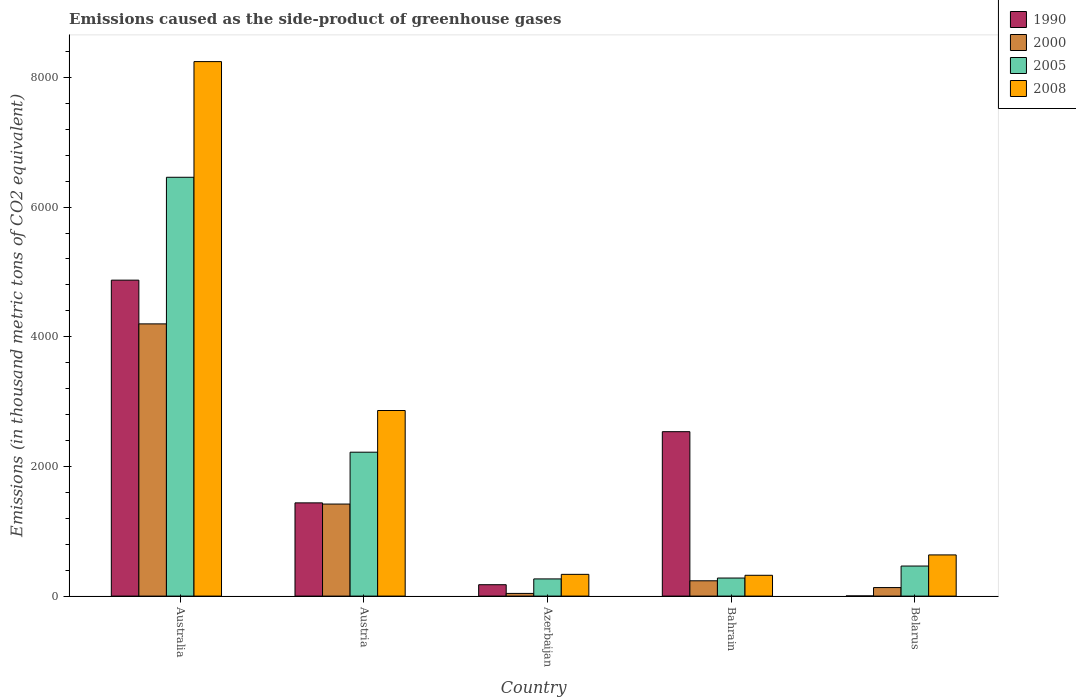Are the number of bars on each tick of the X-axis equal?
Your response must be concise. Yes. How many bars are there on the 1st tick from the left?
Your answer should be very brief. 4. What is the label of the 3rd group of bars from the left?
Give a very brief answer. Azerbaijan. What is the emissions caused as the side-product of greenhouse gases in 2008 in Australia?
Give a very brief answer. 8243.5. Across all countries, what is the maximum emissions caused as the side-product of greenhouse gases in 2000?
Your answer should be compact. 4198.3. Across all countries, what is the minimum emissions caused as the side-product of greenhouse gases in 2008?
Offer a very short reply. 320.9. In which country was the emissions caused as the side-product of greenhouse gases in 1990 minimum?
Give a very brief answer. Belarus. What is the total emissions caused as the side-product of greenhouse gases in 2005 in the graph?
Ensure brevity in your answer.  9686.4. What is the difference between the emissions caused as the side-product of greenhouse gases in 2000 in Bahrain and that in Belarus?
Your answer should be compact. 104.5. What is the difference between the emissions caused as the side-product of greenhouse gases in 2008 in Azerbaijan and the emissions caused as the side-product of greenhouse gases in 2000 in Australia?
Provide a succinct answer. -3863. What is the average emissions caused as the side-product of greenhouse gases in 2000 per country?
Offer a very short reply. 1205.36. What is the difference between the emissions caused as the side-product of greenhouse gases of/in 2000 and emissions caused as the side-product of greenhouse gases of/in 2005 in Australia?
Give a very brief answer. -2261.3. What is the ratio of the emissions caused as the side-product of greenhouse gases in 2005 in Australia to that in Austria?
Give a very brief answer. 2.91. What is the difference between the highest and the second highest emissions caused as the side-product of greenhouse gases in 2008?
Provide a short and direct response. -7608.3. What is the difference between the highest and the lowest emissions caused as the side-product of greenhouse gases in 2000?
Your answer should be very brief. 4157. What does the 3rd bar from the left in Bahrain represents?
Ensure brevity in your answer.  2005. What does the 3rd bar from the right in Bahrain represents?
Ensure brevity in your answer.  2000. Is it the case that in every country, the sum of the emissions caused as the side-product of greenhouse gases in 2008 and emissions caused as the side-product of greenhouse gases in 2000 is greater than the emissions caused as the side-product of greenhouse gases in 1990?
Provide a short and direct response. No. How many bars are there?
Your response must be concise. 20. Are all the bars in the graph horizontal?
Ensure brevity in your answer.  No. How many countries are there in the graph?
Offer a terse response. 5. What is the difference between two consecutive major ticks on the Y-axis?
Provide a short and direct response. 2000. Where does the legend appear in the graph?
Give a very brief answer. Top right. How many legend labels are there?
Make the answer very short. 4. What is the title of the graph?
Your answer should be very brief. Emissions caused as the side-product of greenhouse gases. Does "1972" appear as one of the legend labels in the graph?
Your answer should be compact. No. What is the label or title of the X-axis?
Provide a short and direct response. Country. What is the label or title of the Y-axis?
Provide a succinct answer. Emissions (in thousand metric tons of CO2 equivalent). What is the Emissions (in thousand metric tons of CO2 equivalent) in 1990 in Australia?
Provide a short and direct response. 4872.8. What is the Emissions (in thousand metric tons of CO2 equivalent) of 2000 in Australia?
Ensure brevity in your answer.  4198.3. What is the Emissions (in thousand metric tons of CO2 equivalent) of 2005 in Australia?
Provide a succinct answer. 6459.6. What is the Emissions (in thousand metric tons of CO2 equivalent) in 2008 in Australia?
Ensure brevity in your answer.  8243.5. What is the Emissions (in thousand metric tons of CO2 equivalent) of 1990 in Austria?
Ensure brevity in your answer.  1437.8. What is the Emissions (in thousand metric tons of CO2 equivalent) of 2000 in Austria?
Offer a very short reply. 1419.5. What is the Emissions (in thousand metric tons of CO2 equivalent) of 2005 in Austria?
Your answer should be very brief. 2219.5. What is the Emissions (in thousand metric tons of CO2 equivalent) of 2008 in Austria?
Make the answer very short. 2862.4. What is the Emissions (in thousand metric tons of CO2 equivalent) in 1990 in Azerbaijan?
Offer a terse response. 175.6. What is the Emissions (in thousand metric tons of CO2 equivalent) of 2000 in Azerbaijan?
Give a very brief answer. 41.3. What is the Emissions (in thousand metric tons of CO2 equivalent) of 2005 in Azerbaijan?
Your answer should be very brief. 265.1. What is the Emissions (in thousand metric tons of CO2 equivalent) in 2008 in Azerbaijan?
Offer a very short reply. 335.3. What is the Emissions (in thousand metric tons of CO2 equivalent) in 1990 in Bahrain?
Your answer should be compact. 2535.7. What is the Emissions (in thousand metric tons of CO2 equivalent) in 2000 in Bahrain?
Offer a very short reply. 236.1. What is the Emissions (in thousand metric tons of CO2 equivalent) in 2005 in Bahrain?
Provide a succinct answer. 278.6. What is the Emissions (in thousand metric tons of CO2 equivalent) of 2008 in Bahrain?
Ensure brevity in your answer.  320.9. What is the Emissions (in thousand metric tons of CO2 equivalent) in 1990 in Belarus?
Provide a succinct answer. 2.6. What is the Emissions (in thousand metric tons of CO2 equivalent) of 2000 in Belarus?
Offer a terse response. 131.6. What is the Emissions (in thousand metric tons of CO2 equivalent) of 2005 in Belarus?
Provide a short and direct response. 463.6. What is the Emissions (in thousand metric tons of CO2 equivalent) of 2008 in Belarus?
Offer a terse response. 635.2. Across all countries, what is the maximum Emissions (in thousand metric tons of CO2 equivalent) in 1990?
Keep it short and to the point. 4872.8. Across all countries, what is the maximum Emissions (in thousand metric tons of CO2 equivalent) of 2000?
Keep it short and to the point. 4198.3. Across all countries, what is the maximum Emissions (in thousand metric tons of CO2 equivalent) in 2005?
Offer a very short reply. 6459.6. Across all countries, what is the maximum Emissions (in thousand metric tons of CO2 equivalent) of 2008?
Your response must be concise. 8243.5. Across all countries, what is the minimum Emissions (in thousand metric tons of CO2 equivalent) in 1990?
Provide a succinct answer. 2.6. Across all countries, what is the minimum Emissions (in thousand metric tons of CO2 equivalent) in 2000?
Provide a succinct answer. 41.3. Across all countries, what is the minimum Emissions (in thousand metric tons of CO2 equivalent) in 2005?
Make the answer very short. 265.1. Across all countries, what is the minimum Emissions (in thousand metric tons of CO2 equivalent) in 2008?
Offer a very short reply. 320.9. What is the total Emissions (in thousand metric tons of CO2 equivalent) of 1990 in the graph?
Ensure brevity in your answer.  9024.5. What is the total Emissions (in thousand metric tons of CO2 equivalent) of 2000 in the graph?
Provide a short and direct response. 6026.8. What is the total Emissions (in thousand metric tons of CO2 equivalent) in 2005 in the graph?
Give a very brief answer. 9686.4. What is the total Emissions (in thousand metric tons of CO2 equivalent) in 2008 in the graph?
Give a very brief answer. 1.24e+04. What is the difference between the Emissions (in thousand metric tons of CO2 equivalent) in 1990 in Australia and that in Austria?
Your answer should be compact. 3435. What is the difference between the Emissions (in thousand metric tons of CO2 equivalent) of 2000 in Australia and that in Austria?
Your answer should be compact. 2778.8. What is the difference between the Emissions (in thousand metric tons of CO2 equivalent) of 2005 in Australia and that in Austria?
Keep it short and to the point. 4240.1. What is the difference between the Emissions (in thousand metric tons of CO2 equivalent) of 2008 in Australia and that in Austria?
Keep it short and to the point. 5381.1. What is the difference between the Emissions (in thousand metric tons of CO2 equivalent) in 1990 in Australia and that in Azerbaijan?
Your answer should be compact. 4697.2. What is the difference between the Emissions (in thousand metric tons of CO2 equivalent) in 2000 in Australia and that in Azerbaijan?
Provide a succinct answer. 4157. What is the difference between the Emissions (in thousand metric tons of CO2 equivalent) of 2005 in Australia and that in Azerbaijan?
Ensure brevity in your answer.  6194.5. What is the difference between the Emissions (in thousand metric tons of CO2 equivalent) of 2008 in Australia and that in Azerbaijan?
Offer a very short reply. 7908.2. What is the difference between the Emissions (in thousand metric tons of CO2 equivalent) in 1990 in Australia and that in Bahrain?
Your response must be concise. 2337.1. What is the difference between the Emissions (in thousand metric tons of CO2 equivalent) of 2000 in Australia and that in Bahrain?
Give a very brief answer. 3962.2. What is the difference between the Emissions (in thousand metric tons of CO2 equivalent) of 2005 in Australia and that in Bahrain?
Your answer should be very brief. 6181. What is the difference between the Emissions (in thousand metric tons of CO2 equivalent) in 2008 in Australia and that in Bahrain?
Offer a terse response. 7922.6. What is the difference between the Emissions (in thousand metric tons of CO2 equivalent) of 1990 in Australia and that in Belarus?
Your answer should be compact. 4870.2. What is the difference between the Emissions (in thousand metric tons of CO2 equivalent) in 2000 in Australia and that in Belarus?
Offer a terse response. 4066.7. What is the difference between the Emissions (in thousand metric tons of CO2 equivalent) of 2005 in Australia and that in Belarus?
Keep it short and to the point. 5996. What is the difference between the Emissions (in thousand metric tons of CO2 equivalent) in 2008 in Australia and that in Belarus?
Keep it short and to the point. 7608.3. What is the difference between the Emissions (in thousand metric tons of CO2 equivalent) in 1990 in Austria and that in Azerbaijan?
Offer a very short reply. 1262.2. What is the difference between the Emissions (in thousand metric tons of CO2 equivalent) in 2000 in Austria and that in Azerbaijan?
Offer a very short reply. 1378.2. What is the difference between the Emissions (in thousand metric tons of CO2 equivalent) of 2005 in Austria and that in Azerbaijan?
Provide a succinct answer. 1954.4. What is the difference between the Emissions (in thousand metric tons of CO2 equivalent) of 2008 in Austria and that in Azerbaijan?
Give a very brief answer. 2527.1. What is the difference between the Emissions (in thousand metric tons of CO2 equivalent) of 1990 in Austria and that in Bahrain?
Ensure brevity in your answer.  -1097.9. What is the difference between the Emissions (in thousand metric tons of CO2 equivalent) in 2000 in Austria and that in Bahrain?
Offer a terse response. 1183.4. What is the difference between the Emissions (in thousand metric tons of CO2 equivalent) in 2005 in Austria and that in Bahrain?
Give a very brief answer. 1940.9. What is the difference between the Emissions (in thousand metric tons of CO2 equivalent) of 2008 in Austria and that in Bahrain?
Offer a very short reply. 2541.5. What is the difference between the Emissions (in thousand metric tons of CO2 equivalent) of 1990 in Austria and that in Belarus?
Your answer should be compact. 1435.2. What is the difference between the Emissions (in thousand metric tons of CO2 equivalent) of 2000 in Austria and that in Belarus?
Provide a short and direct response. 1287.9. What is the difference between the Emissions (in thousand metric tons of CO2 equivalent) in 2005 in Austria and that in Belarus?
Give a very brief answer. 1755.9. What is the difference between the Emissions (in thousand metric tons of CO2 equivalent) of 2008 in Austria and that in Belarus?
Make the answer very short. 2227.2. What is the difference between the Emissions (in thousand metric tons of CO2 equivalent) of 1990 in Azerbaijan and that in Bahrain?
Offer a very short reply. -2360.1. What is the difference between the Emissions (in thousand metric tons of CO2 equivalent) of 2000 in Azerbaijan and that in Bahrain?
Your response must be concise. -194.8. What is the difference between the Emissions (in thousand metric tons of CO2 equivalent) of 2005 in Azerbaijan and that in Bahrain?
Offer a terse response. -13.5. What is the difference between the Emissions (in thousand metric tons of CO2 equivalent) in 2008 in Azerbaijan and that in Bahrain?
Your response must be concise. 14.4. What is the difference between the Emissions (in thousand metric tons of CO2 equivalent) of 1990 in Azerbaijan and that in Belarus?
Offer a very short reply. 173. What is the difference between the Emissions (in thousand metric tons of CO2 equivalent) in 2000 in Azerbaijan and that in Belarus?
Keep it short and to the point. -90.3. What is the difference between the Emissions (in thousand metric tons of CO2 equivalent) in 2005 in Azerbaijan and that in Belarus?
Your response must be concise. -198.5. What is the difference between the Emissions (in thousand metric tons of CO2 equivalent) of 2008 in Azerbaijan and that in Belarus?
Provide a succinct answer. -299.9. What is the difference between the Emissions (in thousand metric tons of CO2 equivalent) in 1990 in Bahrain and that in Belarus?
Offer a terse response. 2533.1. What is the difference between the Emissions (in thousand metric tons of CO2 equivalent) in 2000 in Bahrain and that in Belarus?
Give a very brief answer. 104.5. What is the difference between the Emissions (in thousand metric tons of CO2 equivalent) in 2005 in Bahrain and that in Belarus?
Offer a terse response. -185. What is the difference between the Emissions (in thousand metric tons of CO2 equivalent) of 2008 in Bahrain and that in Belarus?
Provide a short and direct response. -314.3. What is the difference between the Emissions (in thousand metric tons of CO2 equivalent) in 1990 in Australia and the Emissions (in thousand metric tons of CO2 equivalent) in 2000 in Austria?
Ensure brevity in your answer.  3453.3. What is the difference between the Emissions (in thousand metric tons of CO2 equivalent) of 1990 in Australia and the Emissions (in thousand metric tons of CO2 equivalent) of 2005 in Austria?
Keep it short and to the point. 2653.3. What is the difference between the Emissions (in thousand metric tons of CO2 equivalent) in 1990 in Australia and the Emissions (in thousand metric tons of CO2 equivalent) in 2008 in Austria?
Your answer should be compact. 2010.4. What is the difference between the Emissions (in thousand metric tons of CO2 equivalent) in 2000 in Australia and the Emissions (in thousand metric tons of CO2 equivalent) in 2005 in Austria?
Offer a terse response. 1978.8. What is the difference between the Emissions (in thousand metric tons of CO2 equivalent) in 2000 in Australia and the Emissions (in thousand metric tons of CO2 equivalent) in 2008 in Austria?
Offer a very short reply. 1335.9. What is the difference between the Emissions (in thousand metric tons of CO2 equivalent) in 2005 in Australia and the Emissions (in thousand metric tons of CO2 equivalent) in 2008 in Austria?
Offer a terse response. 3597.2. What is the difference between the Emissions (in thousand metric tons of CO2 equivalent) in 1990 in Australia and the Emissions (in thousand metric tons of CO2 equivalent) in 2000 in Azerbaijan?
Offer a terse response. 4831.5. What is the difference between the Emissions (in thousand metric tons of CO2 equivalent) in 1990 in Australia and the Emissions (in thousand metric tons of CO2 equivalent) in 2005 in Azerbaijan?
Offer a very short reply. 4607.7. What is the difference between the Emissions (in thousand metric tons of CO2 equivalent) in 1990 in Australia and the Emissions (in thousand metric tons of CO2 equivalent) in 2008 in Azerbaijan?
Offer a very short reply. 4537.5. What is the difference between the Emissions (in thousand metric tons of CO2 equivalent) in 2000 in Australia and the Emissions (in thousand metric tons of CO2 equivalent) in 2005 in Azerbaijan?
Provide a short and direct response. 3933.2. What is the difference between the Emissions (in thousand metric tons of CO2 equivalent) of 2000 in Australia and the Emissions (in thousand metric tons of CO2 equivalent) of 2008 in Azerbaijan?
Offer a terse response. 3863. What is the difference between the Emissions (in thousand metric tons of CO2 equivalent) in 2005 in Australia and the Emissions (in thousand metric tons of CO2 equivalent) in 2008 in Azerbaijan?
Your answer should be compact. 6124.3. What is the difference between the Emissions (in thousand metric tons of CO2 equivalent) of 1990 in Australia and the Emissions (in thousand metric tons of CO2 equivalent) of 2000 in Bahrain?
Keep it short and to the point. 4636.7. What is the difference between the Emissions (in thousand metric tons of CO2 equivalent) of 1990 in Australia and the Emissions (in thousand metric tons of CO2 equivalent) of 2005 in Bahrain?
Make the answer very short. 4594.2. What is the difference between the Emissions (in thousand metric tons of CO2 equivalent) in 1990 in Australia and the Emissions (in thousand metric tons of CO2 equivalent) in 2008 in Bahrain?
Your answer should be very brief. 4551.9. What is the difference between the Emissions (in thousand metric tons of CO2 equivalent) in 2000 in Australia and the Emissions (in thousand metric tons of CO2 equivalent) in 2005 in Bahrain?
Ensure brevity in your answer.  3919.7. What is the difference between the Emissions (in thousand metric tons of CO2 equivalent) in 2000 in Australia and the Emissions (in thousand metric tons of CO2 equivalent) in 2008 in Bahrain?
Make the answer very short. 3877.4. What is the difference between the Emissions (in thousand metric tons of CO2 equivalent) of 2005 in Australia and the Emissions (in thousand metric tons of CO2 equivalent) of 2008 in Bahrain?
Your answer should be very brief. 6138.7. What is the difference between the Emissions (in thousand metric tons of CO2 equivalent) in 1990 in Australia and the Emissions (in thousand metric tons of CO2 equivalent) in 2000 in Belarus?
Your answer should be compact. 4741.2. What is the difference between the Emissions (in thousand metric tons of CO2 equivalent) of 1990 in Australia and the Emissions (in thousand metric tons of CO2 equivalent) of 2005 in Belarus?
Your answer should be very brief. 4409.2. What is the difference between the Emissions (in thousand metric tons of CO2 equivalent) of 1990 in Australia and the Emissions (in thousand metric tons of CO2 equivalent) of 2008 in Belarus?
Offer a terse response. 4237.6. What is the difference between the Emissions (in thousand metric tons of CO2 equivalent) in 2000 in Australia and the Emissions (in thousand metric tons of CO2 equivalent) in 2005 in Belarus?
Ensure brevity in your answer.  3734.7. What is the difference between the Emissions (in thousand metric tons of CO2 equivalent) of 2000 in Australia and the Emissions (in thousand metric tons of CO2 equivalent) of 2008 in Belarus?
Ensure brevity in your answer.  3563.1. What is the difference between the Emissions (in thousand metric tons of CO2 equivalent) in 2005 in Australia and the Emissions (in thousand metric tons of CO2 equivalent) in 2008 in Belarus?
Your answer should be compact. 5824.4. What is the difference between the Emissions (in thousand metric tons of CO2 equivalent) in 1990 in Austria and the Emissions (in thousand metric tons of CO2 equivalent) in 2000 in Azerbaijan?
Give a very brief answer. 1396.5. What is the difference between the Emissions (in thousand metric tons of CO2 equivalent) of 1990 in Austria and the Emissions (in thousand metric tons of CO2 equivalent) of 2005 in Azerbaijan?
Ensure brevity in your answer.  1172.7. What is the difference between the Emissions (in thousand metric tons of CO2 equivalent) of 1990 in Austria and the Emissions (in thousand metric tons of CO2 equivalent) of 2008 in Azerbaijan?
Provide a succinct answer. 1102.5. What is the difference between the Emissions (in thousand metric tons of CO2 equivalent) of 2000 in Austria and the Emissions (in thousand metric tons of CO2 equivalent) of 2005 in Azerbaijan?
Keep it short and to the point. 1154.4. What is the difference between the Emissions (in thousand metric tons of CO2 equivalent) of 2000 in Austria and the Emissions (in thousand metric tons of CO2 equivalent) of 2008 in Azerbaijan?
Your answer should be very brief. 1084.2. What is the difference between the Emissions (in thousand metric tons of CO2 equivalent) of 2005 in Austria and the Emissions (in thousand metric tons of CO2 equivalent) of 2008 in Azerbaijan?
Keep it short and to the point. 1884.2. What is the difference between the Emissions (in thousand metric tons of CO2 equivalent) in 1990 in Austria and the Emissions (in thousand metric tons of CO2 equivalent) in 2000 in Bahrain?
Keep it short and to the point. 1201.7. What is the difference between the Emissions (in thousand metric tons of CO2 equivalent) of 1990 in Austria and the Emissions (in thousand metric tons of CO2 equivalent) of 2005 in Bahrain?
Keep it short and to the point. 1159.2. What is the difference between the Emissions (in thousand metric tons of CO2 equivalent) of 1990 in Austria and the Emissions (in thousand metric tons of CO2 equivalent) of 2008 in Bahrain?
Your answer should be very brief. 1116.9. What is the difference between the Emissions (in thousand metric tons of CO2 equivalent) in 2000 in Austria and the Emissions (in thousand metric tons of CO2 equivalent) in 2005 in Bahrain?
Your response must be concise. 1140.9. What is the difference between the Emissions (in thousand metric tons of CO2 equivalent) of 2000 in Austria and the Emissions (in thousand metric tons of CO2 equivalent) of 2008 in Bahrain?
Provide a short and direct response. 1098.6. What is the difference between the Emissions (in thousand metric tons of CO2 equivalent) in 2005 in Austria and the Emissions (in thousand metric tons of CO2 equivalent) in 2008 in Bahrain?
Make the answer very short. 1898.6. What is the difference between the Emissions (in thousand metric tons of CO2 equivalent) of 1990 in Austria and the Emissions (in thousand metric tons of CO2 equivalent) of 2000 in Belarus?
Provide a short and direct response. 1306.2. What is the difference between the Emissions (in thousand metric tons of CO2 equivalent) in 1990 in Austria and the Emissions (in thousand metric tons of CO2 equivalent) in 2005 in Belarus?
Offer a very short reply. 974.2. What is the difference between the Emissions (in thousand metric tons of CO2 equivalent) in 1990 in Austria and the Emissions (in thousand metric tons of CO2 equivalent) in 2008 in Belarus?
Your answer should be compact. 802.6. What is the difference between the Emissions (in thousand metric tons of CO2 equivalent) in 2000 in Austria and the Emissions (in thousand metric tons of CO2 equivalent) in 2005 in Belarus?
Give a very brief answer. 955.9. What is the difference between the Emissions (in thousand metric tons of CO2 equivalent) in 2000 in Austria and the Emissions (in thousand metric tons of CO2 equivalent) in 2008 in Belarus?
Ensure brevity in your answer.  784.3. What is the difference between the Emissions (in thousand metric tons of CO2 equivalent) of 2005 in Austria and the Emissions (in thousand metric tons of CO2 equivalent) of 2008 in Belarus?
Provide a short and direct response. 1584.3. What is the difference between the Emissions (in thousand metric tons of CO2 equivalent) of 1990 in Azerbaijan and the Emissions (in thousand metric tons of CO2 equivalent) of 2000 in Bahrain?
Keep it short and to the point. -60.5. What is the difference between the Emissions (in thousand metric tons of CO2 equivalent) in 1990 in Azerbaijan and the Emissions (in thousand metric tons of CO2 equivalent) in 2005 in Bahrain?
Provide a short and direct response. -103. What is the difference between the Emissions (in thousand metric tons of CO2 equivalent) of 1990 in Azerbaijan and the Emissions (in thousand metric tons of CO2 equivalent) of 2008 in Bahrain?
Offer a very short reply. -145.3. What is the difference between the Emissions (in thousand metric tons of CO2 equivalent) of 2000 in Azerbaijan and the Emissions (in thousand metric tons of CO2 equivalent) of 2005 in Bahrain?
Offer a very short reply. -237.3. What is the difference between the Emissions (in thousand metric tons of CO2 equivalent) of 2000 in Azerbaijan and the Emissions (in thousand metric tons of CO2 equivalent) of 2008 in Bahrain?
Make the answer very short. -279.6. What is the difference between the Emissions (in thousand metric tons of CO2 equivalent) of 2005 in Azerbaijan and the Emissions (in thousand metric tons of CO2 equivalent) of 2008 in Bahrain?
Give a very brief answer. -55.8. What is the difference between the Emissions (in thousand metric tons of CO2 equivalent) in 1990 in Azerbaijan and the Emissions (in thousand metric tons of CO2 equivalent) in 2000 in Belarus?
Your answer should be very brief. 44. What is the difference between the Emissions (in thousand metric tons of CO2 equivalent) in 1990 in Azerbaijan and the Emissions (in thousand metric tons of CO2 equivalent) in 2005 in Belarus?
Keep it short and to the point. -288. What is the difference between the Emissions (in thousand metric tons of CO2 equivalent) in 1990 in Azerbaijan and the Emissions (in thousand metric tons of CO2 equivalent) in 2008 in Belarus?
Your response must be concise. -459.6. What is the difference between the Emissions (in thousand metric tons of CO2 equivalent) of 2000 in Azerbaijan and the Emissions (in thousand metric tons of CO2 equivalent) of 2005 in Belarus?
Ensure brevity in your answer.  -422.3. What is the difference between the Emissions (in thousand metric tons of CO2 equivalent) in 2000 in Azerbaijan and the Emissions (in thousand metric tons of CO2 equivalent) in 2008 in Belarus?
Make the answer very short. -593.9. What is the difference between the Emissions (in thousand metric tons of CO2 equivalent) in 2005 in Azerbaijan and the Emissions (in thousand metric tons of CO2 equivalent) in 2008 in Belarus?
Provide a succinct answer. -370.1. What is the difference between the Emissions (in thousand metric tons of CO2 equivalent) of 1990 in Bahrain and the Emissions (in thousand metric tons of CO2 equivalent) of 2000 in Belarus?
Offer a terse response. 2404.1. What is the difference between the Emissions (in thousand metric tons of CO2 equivalent) of 1990 in Bahrain and the Emissions (in thousand metric tons of CO2 equivalent) of 2005 in Belarus?
Your answer should be compact. 2072.1. What is the difference between the Emissions (in thousand metric tons of CO2 equivalent) in 1990 in Bahrain and the Emissions (in thousand metric tons of CO2 equivalent) in 2008 in Belarus?
Your response must be concise. 1900.5. What is the difference between the Emissions (in thousand metric tons of CO2 equivalent) of 2000 in Bahrain and the Emissions (in thousand metric tons of CO2 equivalent) of 2005 in Belarus?
Provide a short and direct response. -227.5. What is the difference between the Emissions (in thousand metric tons of CO2 equivalent) of 2000 in Bahrain and the Emissions (in thousand metric tons of CO2 equivalent) of 2008 in Belarus?
Your answer should be compact. -399.1. What is the difference between the Emissions (in thousand metric tons of CO2 equivalent) of 2005 in Bahrain and the Emissions (in thousand metric tons of CO2 equivalent) of 2008 in Belarus?
Keep it short and to the point. -356.6. What is the average Emissions (in thousand metric tons of CO2 equivalent) in 1990 per country?
Make the answer very short. 1804.9. What is the average Emissions (in thousand metric tons of CO2 equivalent) in 2000 per country?
Your answer should be very brief. 1205.36. What is the average Emissions (in thousand metric tons of CO2 equivalent) in 2005 per country?
Offer a terse response. 1937.28. What is the average Emissions (in thousand metric tons of CO2 equivalent) in 2008 per country?
Keep it short and to the point. 2479.46. What is the difference between the Emissions (in thousand metric tons of CO2 equivalent) in 1990 and Emissions (in thousand metric tons of CO2 equivalent) in 2000 in Australia?
Offer a very short reply. 674.5. What is the difference between the Emissions (in thousand metric tons of CO2 equivalent) in 1990 and Emissions (in thousand metric tons of CO2 equivalent) in 2005 in Australia?
Your response must be concise. -1586.8. What is the difference between the Emissions (in thousand metric tons of CO2 equivalent) of 1990 and Emissions (in thousand metric tons of CO2 equivalent) of 2008 in Australia?
Your answer should be very brief. -3370.7. What is the difference between the Emissions (in thousand metric tons of CO2 equivalent) in 2000 and Emissions (in thousand metric tons of CO2 equivalent) in 2005 in Australia?
Ensure brevity in your answer.  -2261.3. What is the difference between the Emissions (in thousand metric tons of CO2 equivalent) in 2000 and Emissions (in thousand metric tons of CO2 equivalent) in 2008 in Australia?
Ensure brevity in your answer.  -4045.2. What is the difference between the Emissions (in thousand metric tons of CO2 equivalent) of 2005 and Emissions (in thousand metric tons of CO2 equivalent) of 2008 in Australia?
Keep it short and to the point. -1783.9. What is the difference between the Emissions (in thousand metric tons of CO2 equivalent) in 1990 and Emissions (in thousand metric tons of CO2 equivalent) in 2000 in Austria?
Offer a terse response. 18.3. What is the difference between the Emissions (in thousand metric tons of CO2 equivalent) of 1990 and Emissions (in thousand metric tons of CO2 equivalent) of 2005 in Austria?
Provide a short and direct response. -781.7. What is the difference between the Emissions (in thousand metric tons of CO2 equivalent) in 1990 and Emissions (in thousand metric tons of CO2 equivalent) in 2008 in Austria?
Provide a succinct answer. -1424.6. What is the difference between the Emissions (in thousand metric tons of CO2 equivalent) in 2000 and Emissions (in thousand metric tons of CO2 equivalent) in 2005 in Austria?
Offer a terse response. -800. What is the difference between the Emissions (in thousand metric tons of CO2 equivalent) of 2000 and Emissions (in thousand metric tons of CO2 equivalent) of 2008 in Austria?
Keep it short and to the point. -1442.9. What is the difference between the Emissions (in thousand metric tons of CO2 equivalent) of 2005 and Emissions (in thousand metric tons of CO2 equivalent) of 2008 in Austria?
Your answer should be compact. -642.9. What is the difference between the Emissions (in thousand metric tons of CO2 equivalent) in 1990 and Emissions (in thousand metric tons of CO2 equivalent) in 2000 in Azerbaijan?
Your answer should be very brief. 134.3. What is the difference between the Emissions (in thousand metric tons of CO2 equivalent) of 1990 and Emissions (in thousand metric tons of CO2 equivalent) of 2005 in Azerbaijan?
Give a very brief answer. -89.5. What is the difference between the Emissions (in thousand metric tons of CO2 equivalent) of 1990 and Emissions (in thousand metric tons of CO2 equivalent) of 2008 in Azerbaijan?
Keep it short and to the point. -159.7. What is the difference between the Emissions (in thousand metric tons of CO2 equivalent) of 2000 and Emissions (in thousand metric tons of CO2 equivalent) of 2005 in Azerbaijan?
Your response must be concise. -223.8. What is the difference between the Emissions (in thousand metric tons of CO2 equivalent) in 2000 and Emissions (in thousand metric tons of CO2 equivalent) in 2008 in Azerbaijan?
Offer a terse response. -294. What is the difference between the Emissions (in thousand metric tons of CO2 equivalent) of 2005 and Emissions (in thousand metric tons of CO2 equivalent) of 2008 in Azerbaijan?
Provide a succinct answer. -70.2. What is the difference between the Emissions (in thousand metric tons of CO2 equivalent) in 1990 and Emissions (in thousand metric tons of CO2 equivalent) in 2000 in Bahrain?
Provide a short and direct response. 2299.6. What is the difference between the Emissions (in thousand metric tons of CO2 equivalent) of 1990 and Emissions (in thousand metric tons of CO2 equivalent) of 2005 in Bahrain?
Your answer should be compact. 2257.1. What is the difference between the Emissions (in thousand metric tons of CO2 equivalent) of 1990 and Emissions (in thousand metric tons of CO2 equivalent) of 2008 in Bahrain?
Make the answer very short. 2214.8. What is the difference between the Emissions (in thousand metric tons of CO2 equivalent) in 2000 and Emissions (in thousand metric tons of CO2 equivalent) in 2005 in Bahrain?
Your answer should be very brief. -42.5. What is the difference between the Emissions (in thousand metric tons of CO2 equivalent) in 2000 and Emissions (in thousand metric tons of CO2 equivalent) in 2008 in Bahrain?
Make the answer very short. -84.8. What is the difference between the Emissions (in thousand metric tons of CO2 equivalent) in 2005 and Emissions (in thousand metric tons of CO2 equivalent) in 2008 in Bahrain?
Offer a terse response. -42.3. What is the difference between the Emissions (in thousand metric tons of CO2 equivalent) in 1990 and Emissions (in thousand metric tons of CO2 equivalent) in 2000 in Belarus?
Keep it short and to the point. -129. What is the difference between the Emissions (in thousand metric tons of CO2 equivalent) of 1990 and Emissions (in thousand metric tons of CO2 equivalent) of 2005 in Belarus?
Provide a succinct answer. -461. What is the difference between the Emissions (in thousand metric tons of CO2 equivalent) of 1990 and Emissions (in thousand metric tons of CO2 equivalent) of 2008 in Belarus?
Give a very brief answer. -632.6. What is the difference between the Emissions (in thousand metric tons of CO2 equivalent) in 2000 and Emissions (in thousand metric tons of CO2 equivalent) in 2005 in Belarus?
Provide a short and direct response. -332. What is the difference between the Emissions (in thousand metric tons of CO2 equivalent) of 2000 and Emissions (in thousand metric tons of CO2 equivalent) of 2008 in Belarus?
Provide a succinct answer. -503.6. What is the difference between the Emissions (in thousand metric tons of CO2 equivalent) of 2005 and Emissions (in thousand metric tons of CO2 equivalent) of 2008 in Belarus?
Provide a succinct answer. -171.6. What is the ratio of the Emissions (in thousand metric tons of CO2 equivalent) in 1990 in Australia to that in Austria?
Provide a succinct answer. 3.39. What is the ratio of the Emissions (in thousand metric tons of CO2 equivalent) of 2000 in Australia to that in Austria?
Provide a short and direct response. 2.96. What is the ratio of the Emissions (in thousand metric tons of CO2 equivalent) in 2005 in Australia to that in Austria?
Your answer should be very brief. 2.91. What is the ratio of the Emissions (in thousand metric tons of CO2 equivalent) of 2008 in Australia to that in Austria?
Offer a terse response. 2.88. What is the ratio of the Emissions (in thousand metric tons of CO2 equivalent) of 1990 in Australia to that in Azerbaijan?
Make the answer very short. 27.75. What is the ratio of the Emissions (in thousand metric tons of CO2 equivalent) of 2000 in Australia to that in Azerbaijan?
Make the answer very short. 101.65. What is the ratio of the Emissions (in thousand metric tons of CO2 equivalent) in 2005 in Australia to that in Azerbaijan?
Provide a short and direct response. 24.37. What is the ratio of the Emissions (in thousand metric tons of CO2 equivalent) in 2008 in Australia to that in Azerbaijan?
Keep it short and to the point. 24.59. What is the ratio of the Emissions (in thousand metric tons of CO2 equivalent) of 1990 in Australia to that in Bahrain?
Your answer should be compact. 1.92. What is the ratio of the Emissions (in thousand metric tons of CO2 equivalent) in 2000 in Australia to that in Bahrain?
Provide a succinct answer. 17.78. What is the ratio of the Emissions (in thousand metric tons of CO2 equivalent) of 2005 in Australia to that in Bahrain?
Offer a terse response. 23.19. What is the ratio of the Emissions (in thousand metric tons of CO2 equivalent) of 2008 in Australia to that in Bahrain?
Provide a succinct answer. 25.69. What is the ratio of the Emissions (in thousand metric tons of CO2 equivalent) in 1990 in Australia to that in Belarus?
Ensure brevity in your answer.  1874.15. What is the ratio of the Emissions (in thousand metric tons of CO2 equivalent) in 2000 in Australia to that in Belarus?
Make the answer very short. 31.9. What is the ratio of the Emissions (in thousand metric tons of CO2 equivalent) in 2005 in Australia to that in Belarus?
Offer a very short reply. 13.93. What is the ratio of the Emissions (in thousand metric tons of CO2 equivalent) in 2008 in Australia to that in Belarus?
Provide a succinct answer. 12.98. What is the ratio of the Emissions (in thousand metric tons of CO2 equivalent) in 1990 in Austria to that in Azerbaijan?
Provide a short and direct response. 8.19. What is the ratio of the Emissions (in thousand metric tons of CO2 equivalent) of 2000 in Austria to that in Azerbaijan?
Offer a terse response. 34.37. What is the ratio of the Emissions (in thousand metric tons of CO2 equivalent) of 2005 in Austria to that in Azerbaijan?
Provide a short and direct response. 8.37. What is the ratio of the Emissions (in thousand metric tons of CO2 equivalent) in 2008 in Austria to that in Azerbaijan?
Provide a succinct answer. 8.54. What is the ratio of the Emissions (in thousand metric tons of CO2 equivalent) in 1990 in Austria to that in Bahrain?
Offer a very short reply. 0.57. What is the ratio of the Emissions (in thousand metric tons of CO2 equivalent) in 2000 in Austria to that in Bahrain?
Your answer should be compact. 6.01. What is the ratio of the Emissions (in thousand metric tons of CO2 equivalent) of 2005 in Austria to that in Bahrain?
Keep it short and to the point. 7.97. What is the ratio of the Emissions (in thousand metric tons of CO2 equivalent) of 2008 in Austria to that in Bahrain?
Keep it short and to the point. 8.92. What is the ratio of the Emissions (in thousand metric tons of CO2 equivalent) in 1990 in Austria to that in Belarus?
Make the answer very short. 553. What is the ratio of the Emissions (in thousand metric tons of CO2 equivalent) of 2000 in Austria to that in Belarus?
Offer a terse response. 10.79. What is the ratio of the Emissions (in thousand metric tons of CO2 equivalent) in 2005 in Austria to that in Belarus?
Make the answer very short. 4.79. What is the ratio of the Emissions (in thousand metric tons of CO2 equivalent) of 2008 in Austria to that in Belarus?
Ensure brevity in your answer.  4.51. What is the ratio of the Emissions (in thousand metric tons of CO2 equivalent) in 1990 in Azerbaijan to that in Bahrain?
Offer a very short reply. 0.07. What is the ratio of the Emissions (in thousand metric tons of CO2 equivalent) of 2000 in Azerbaijan to that in Bahrain?
Offer a very short reply. 0.17. What is the ratio of the Emissions (in thousand metric tons of CO2 equivalent) in 2005 in Azerbaijan to that in Bahrain?
Provide a short and direct response. 0.95. What is the ratio of the Emissions (in thousand metric tons of CO2 equivalent) of 2008 in Azerbaijan to that in Bahrain?
Your answer should be compact. 1.04. What is the ratio of the Emissions (in thousand metric tons of CO2 equivalent) in 1990 in Azerbaijan to that in Belarus?
Provide a short and direct response. 67.54. What is the ratio of the Emissions (in thousand metric tons of CO2 equivalent) of 2000 in Azerbaijan to that in Belarus?
Offer a very short reply. 0.31. What is the ratio of the Emissions (in thousand metric tons of CO2 equivalent) in 2005 in Azerbaijan to that in Belarus?
Provide a succinct answer. 0.57. What is the ratio of the Emissions (in thousand metric tons of CO2 equivalent) of 2008 in Azerbaijan to that in Belarus?
Provide a succinct answer. 0.53. What is the ratio of the Emissions (in thousand metric tons of CO2 equivalent) of 1990 in Bahrain to that in Belarus?
Offer a terse response. 975.27. What is the ratio of the Emissions (in thousand metric tons of CO2 equivalent) in 2000 in Bahrain to that in Belarus?
Provide a short and direct response. 1.79. What is the ratio of the Emissions (in thousand metric tons of CO2 equivalent) of 2005 in Bahrain to that in Belarus?
Offer a terse response. 0.6. What is the ratio of the Emissions (in thousand metric tons of CO2 equivalent) of 2008 in Bahrain to that in Belarus?
Offer a very short reply. 0.51. What is the difference between the highest and the second highest Emissions (in thousand metric tons of CO2 equivalent) in 1990?
Your answer should be compact. 2337.1. What is the difference between the highest and the second highest Emissions (in thousand metric tons of CO2 equivalent) of 2000?
Make the answer very short. 2778.8. What is the difference between the highest and the second highest Emissions (in thousand metric tons of CO2 equivalent) in 2005?
Provide a short and direct response. 4240.1. What is the difference between the highest and the second highest Emissions (in thousand metric tons of CO2 equivalent) of 2008?
Keep it short and to the point. 5381.1. What is the difference between the highest and the lowest Emissions (in thousand metric tons of CO2 equivalent) of 1990?
Offer a very short reply. 4870.2. What is the difference between the highest and the lowest Emissions (in thousand metric tons of CO2 equivalent) in 2000?
Make the answer very short. 4157. What is the difference between the highest and the lowest Emissions (in thousand metric tons of CO2 equivalent) in 2005?
Offer a very short reply. 6194.5. What is the difference between the highest and the lowest Emissions (in thousand metric tons of CO2 equivalent) of 2008?
Your answer should be very brief. 7922.6. 